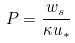Convert formula to latex. <formula><loc_0><loc_0><loc_500><loc_500>P = \frac { w _ { s } } { \kappa u _ { * } }</formula> 